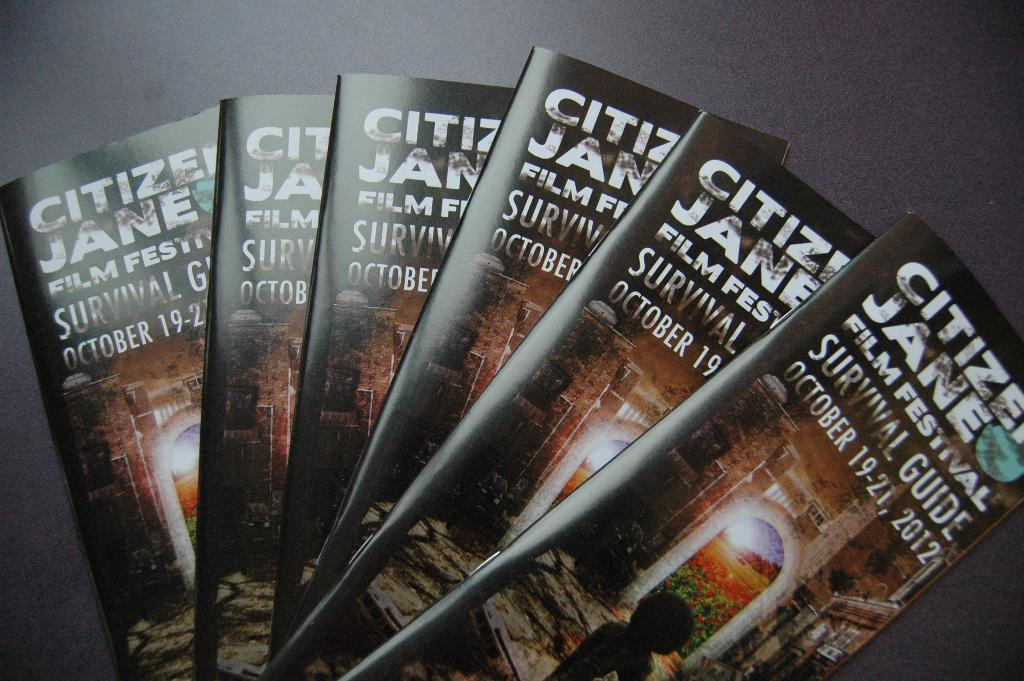Provide a one-sentence caption for the provided image. A stack of Citizen Jane film festival survivor guide pamphlets. 